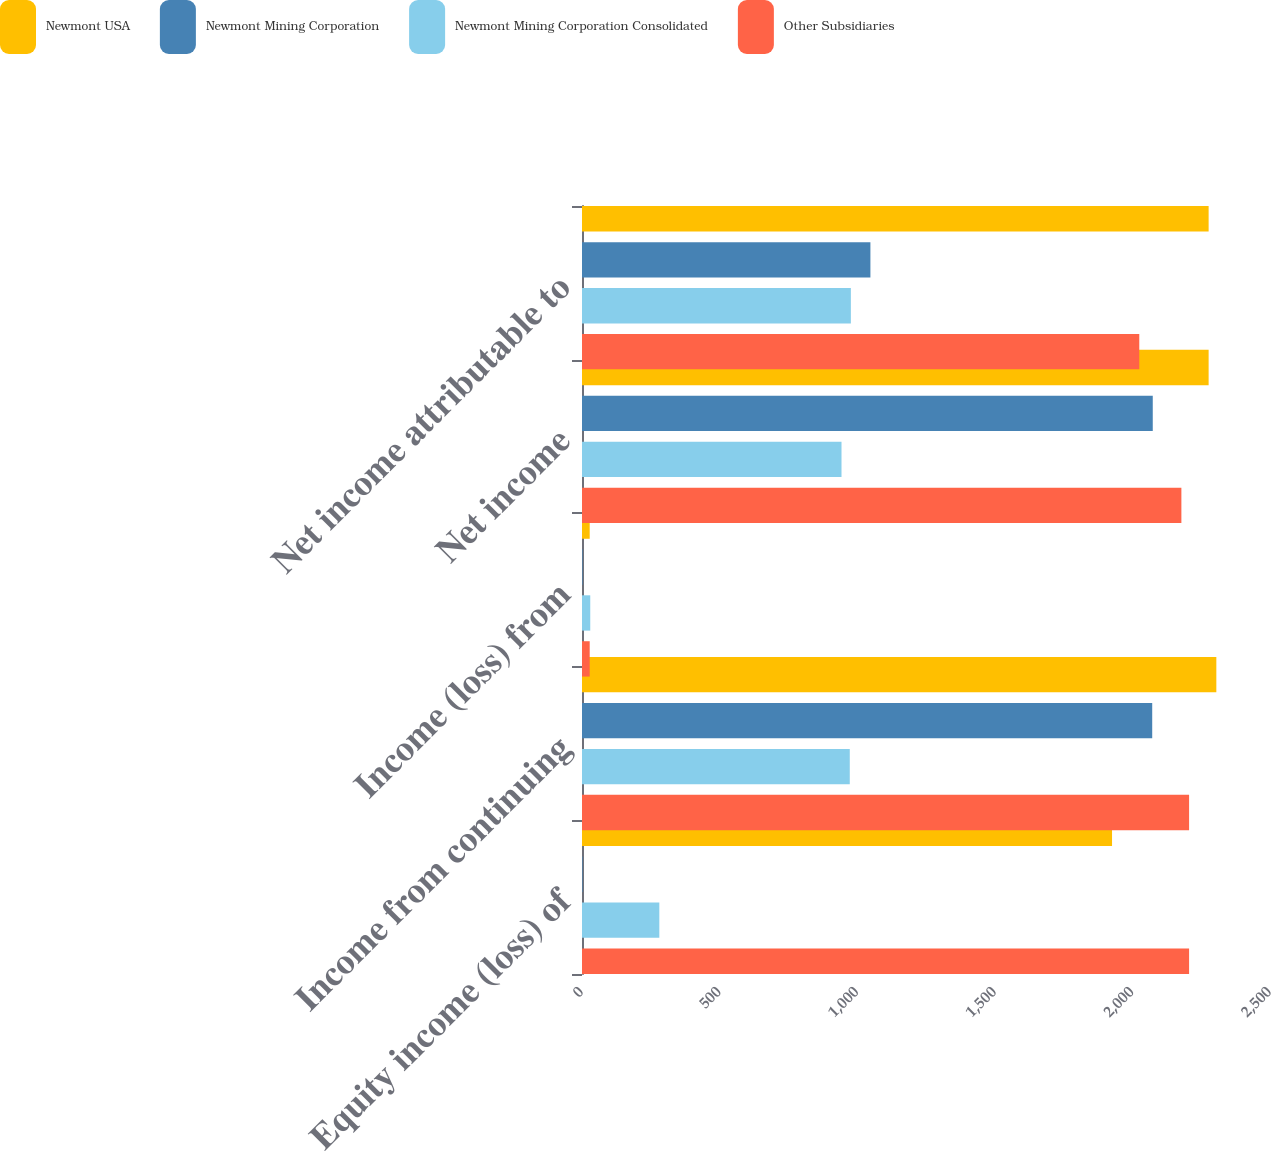<chart> <loc_0><loc_0><loc_500><loc_500><stacked_bar_chart><ecel><fcel>Equity income (loss) of<fcel>Income from continuing<fcel>Income (loss) from<fcel>Net income<fcel>Net income attributable to<nl><fcel>Newmont USA<fcel>1926<fcel>2305<fcel>28<fcel>2277<fcel>2277<nl><fcel>Newmont Mining Corporation<fcel>2<fcel>2072<fcel>2<fcel>2074<fcel>1048<nl><fcel>Newmont Mining Corporation Consolidated<fcel>281<fcel>973<fcel>30<fcel>943<fcel>977<nl><fcel>Other Subsidiaries<fcel>2206<fcel>2206<fcel>28<fcel>2178<fcel>2025<nl></chart> 